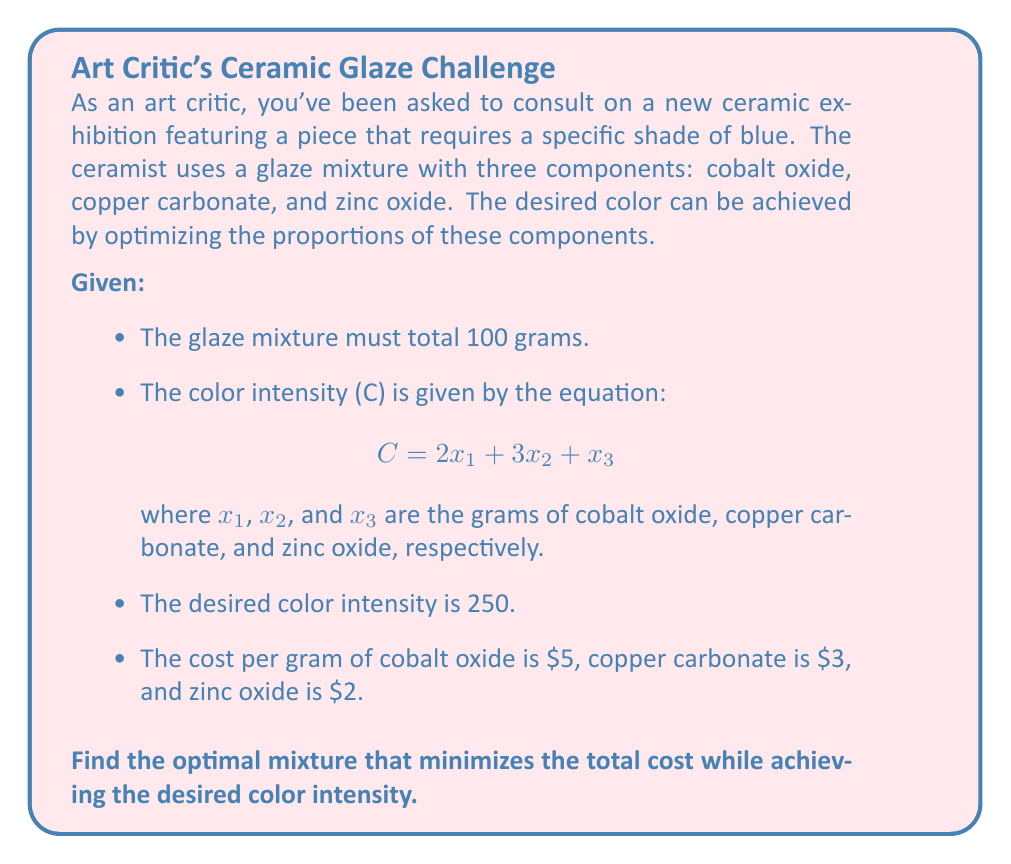Solve this math problem. To solve this optimization problem, we'll use the method of Lagrange multipliers:

1) Define the objective function (total cost):
   $$f(x_1, x_2, x_3) = 5x_1 + 3x_2 + 2x_3$$

2) Define the constraints:
   $$g_1(x_1, x_2, x_3) = x_1 + x_2 + x_3 - 100 = 0$$ (total 100 grams)
   $$g_2(x_1, x_2, x_3) = 2x_1 + 3x_2 + x_3 - 250 = 0$$ (desired color intensity)

3) Form the Lagrangian:
   $$L(x_1, x_2, x_3, \lambda_1, \lambda_2) = f + \lambda_1g_1 + \lambda_2g_2$$

4) Take partial derivatives and set them to zero:
   $$\frac{\partial L}{\partial x_1} = 5 + \lambda_1 + 2\lambda_2 = 0$$
   $$\frac{\partial L}{\partial x_2} = 3 + \lambda_1 + 3\lambda_2 = 0$$
   $$\frac{\partial L}{\partial x_3} = 2 + \lambda_1 + \lambda_2 = 0$$
   $$\frac{\partial L}{\partial \lambda_1} = x_1 + x_2 + x_3 - 100 = 0$$
   $$\frac{\partial L}{\partial \lambda_2} = 2x_1 + 3x_2 + x_3 - 250 = 0$$

5) Solve the system of equations:
   From the first three equations:
   $$\lambda_1 = -2 - \lambda_2$$
   $$\lambda_2 = -1$$
   $$\lambda_1 = -1$$

   Substituting into the last two equations:
   $$x_1 + x_2 + x_3 = 100$$
   $$2x_1 + 3x_2 + x_3 = 250$$

   Solving this system:
   $$x_1 = 50$$
   $$x_2 = 50$$
   $$x_3 = 0$$

6) Verify the solution satisfies the constraints:
   Total mixture: 50 + 50 + 0 = 100 grams
   Color intensity: 2(50) + 3(50) + 0 = 250

Therefore, the optimal mixture is 50 grams of cobalt oxide and 50 grams of copper carbonate.
Answer: 50g cobalt oxide, 50g copper carbonate, 0g zinc oxide 